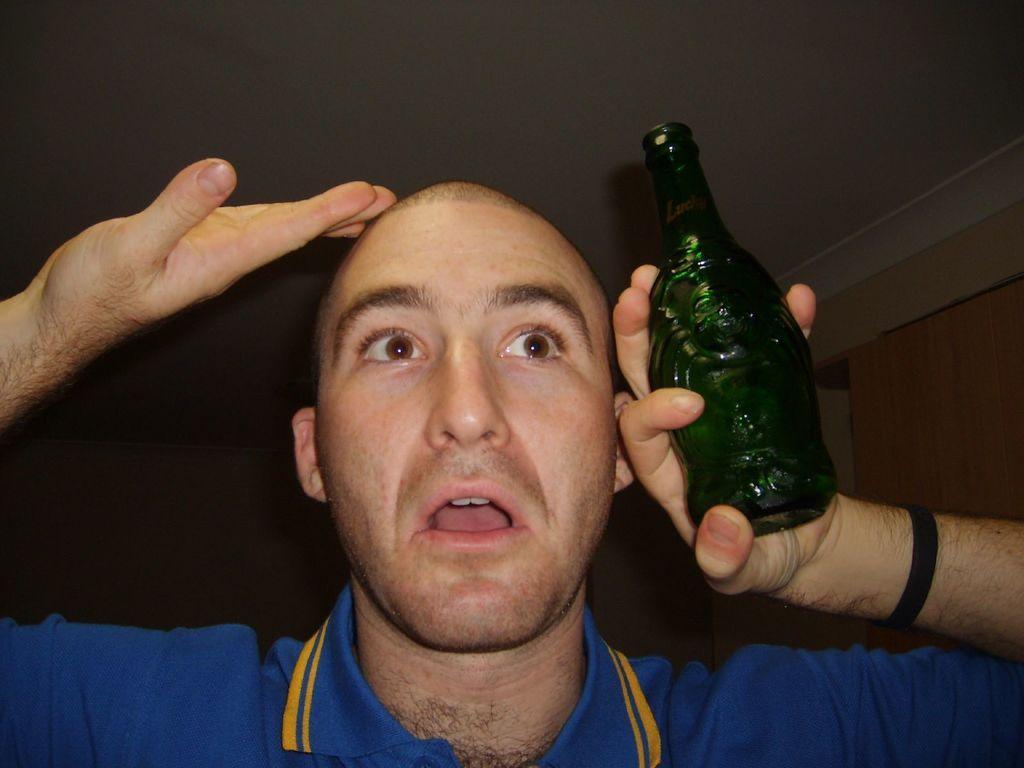Could you give a brief overview of what you see in this image? A person wearing a blue shirt is holding a green bottle. 